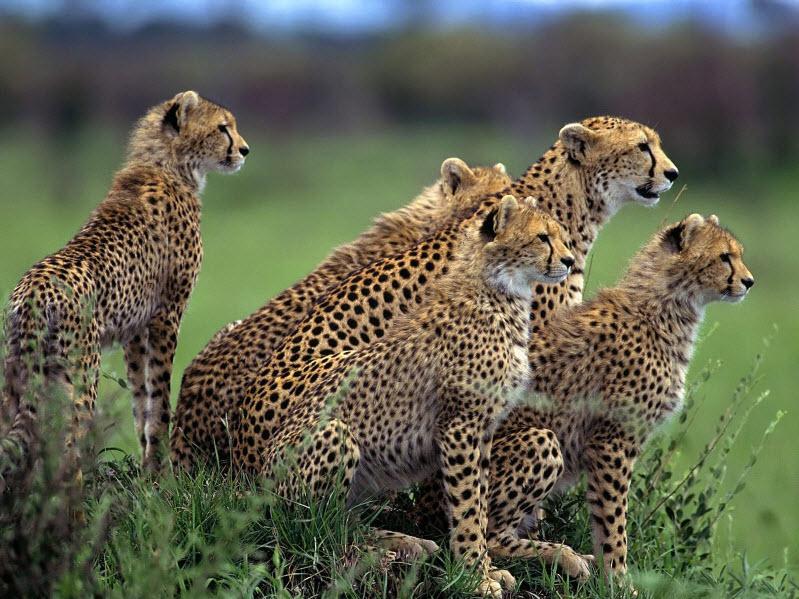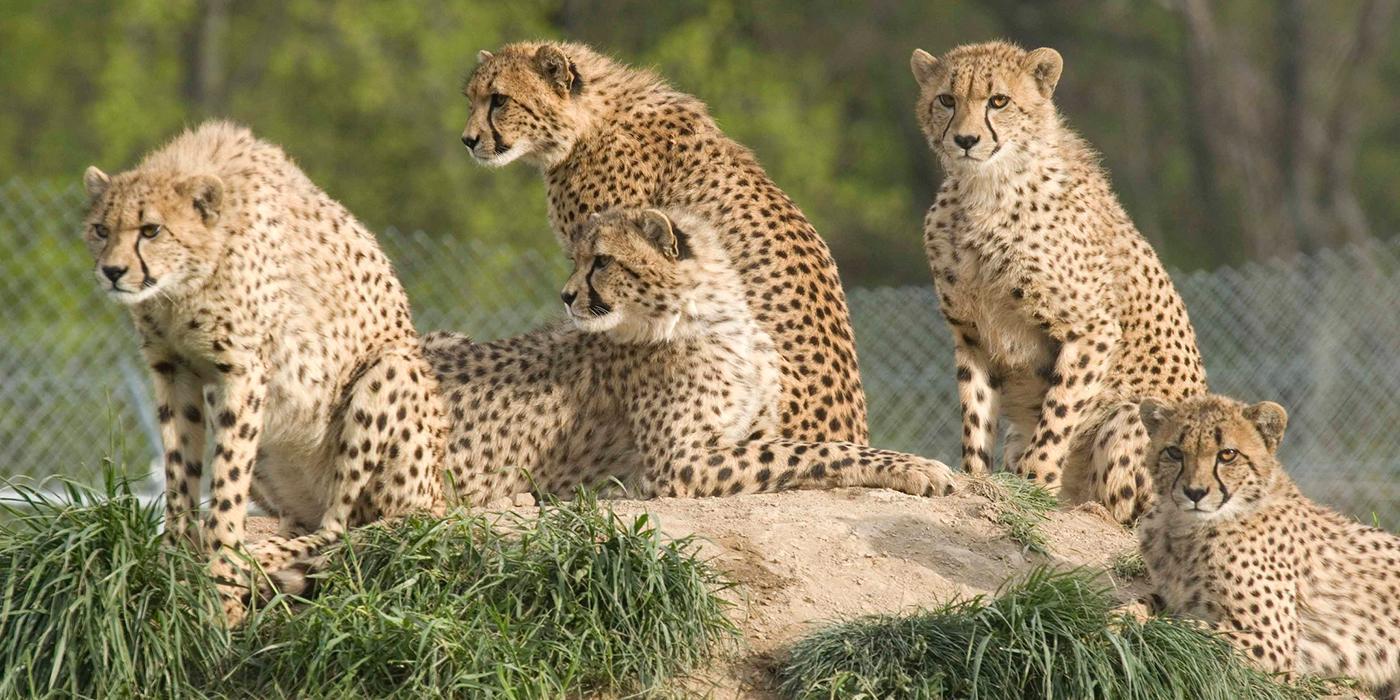The first image is the image on the left, the second image is the image on the right. Assess this claim about the two images: "The left image contains more cheetahs than the right image.". Correct or not? Answer yes or no. No. The first image is the image on the left, the second image is the image on the right. For the images displayed, is the sentence "In the leftmost image there are exactly five cheetahs sitting down." factually correct? Answer yes or no. Yes. 